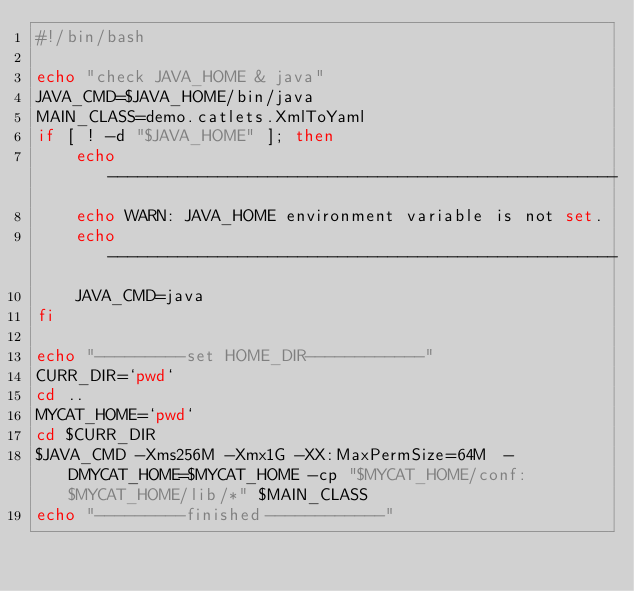<code> <loc_0><loc_0><loc_500><loc_500><_Bash_>#!/bin/bash

echo "check JAVA_HOME & java"
JAVA_CMD=$JAVA_HOME/bin/java
MAIN_CLASS=demo.catlets.XmlToYaml
if [ ! -d "$JAVA_HOME" ]; then
    echo ---------------------------------------------------
    echo WARN: JAVA_HOME environment variable is not set. 
    echo ---------------------------------------------------
    JAVA_CMD=java
fi

echo "---------set HOME_DIR------------"
CURR_DIR=`pwd`
cd ..
MYCAT_HOME=`pwd`
cd $CURR_DIR
$JAVA_CMD -Xms256M -Xmx1G -XX:MaxPermSize=64M  -DMYCAT_HOME=$MYCAT_HOME -cp "$MYCAT_HOME/conf:$MYCAT_HOME/lib/*" $MAIN_CLASS
echo "---------finished------------"
</code> 